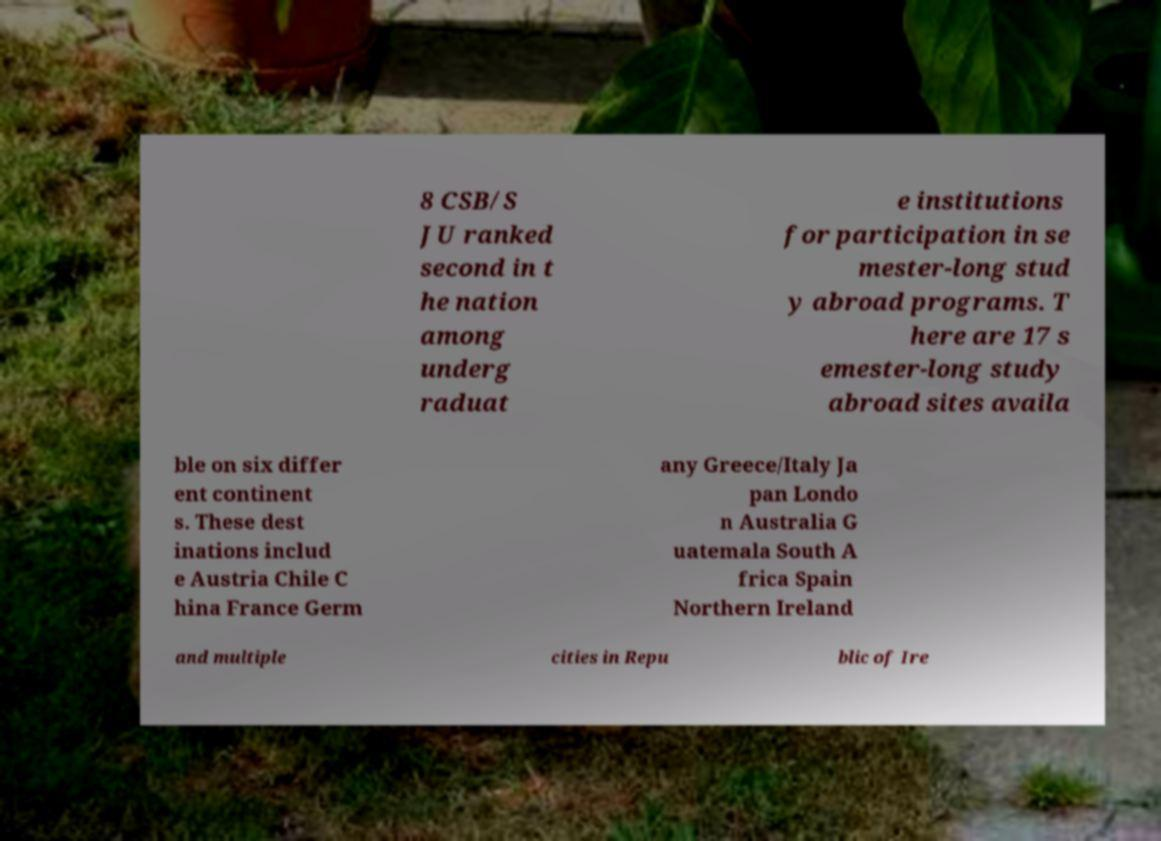Could you extract and type out the text from this image? 8 CSB/S JU ranked second in t he nation among underg raduat e institutions for participation in se mester-long stud y abroad programs. T here are 17 s emester-long study abroad sites availa ble on six differ ent continent s. These dest inations includ e Austria Chile C hina France Germ any Greece/Italy Ja pan Londo n Australia G uatemala South A frica Spain Northern Ireland and multiple cities in Repu blic of Ire 